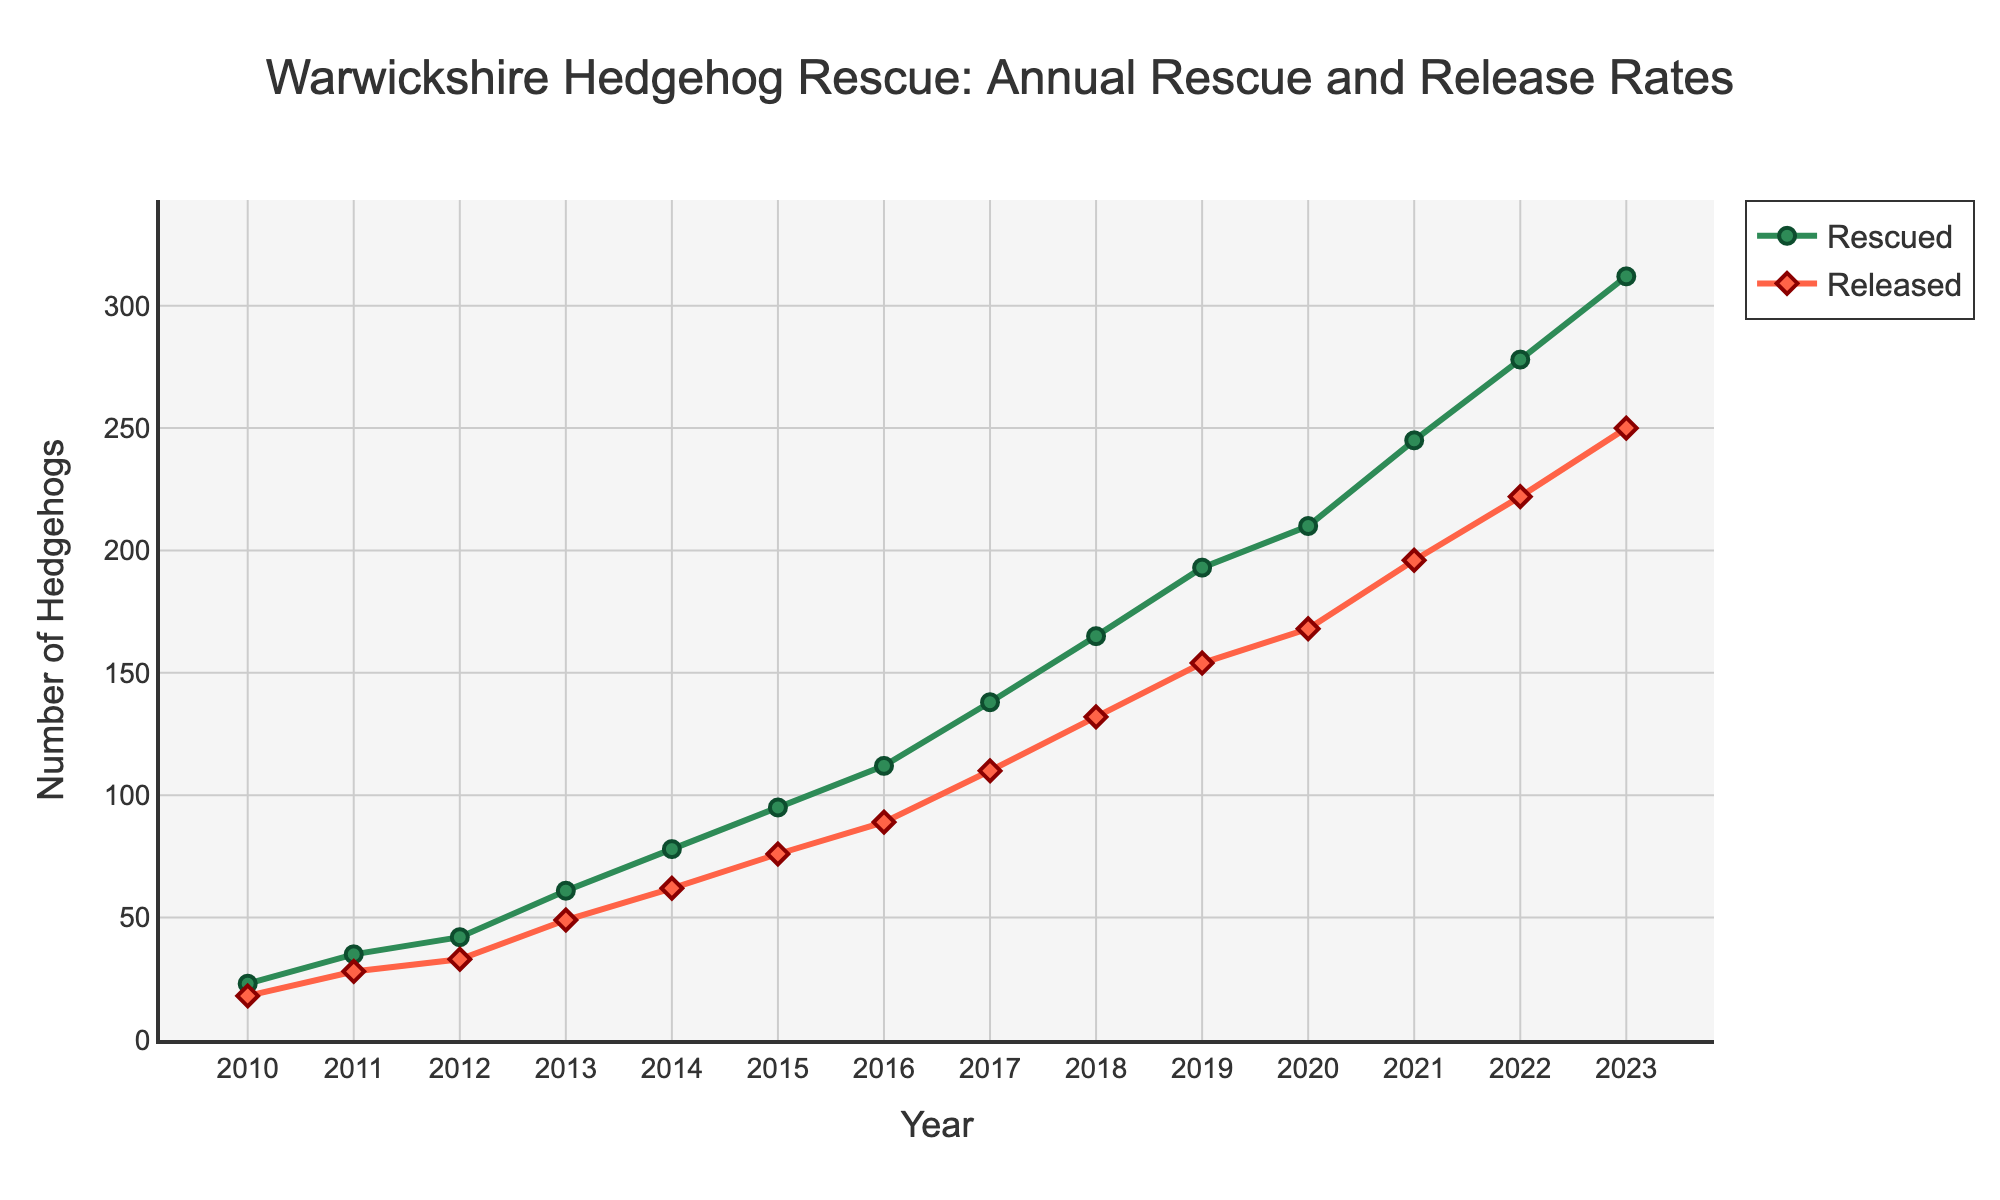What was the total number of hedgehogs rescued over the entire period? Sum the values of the 'Rescued' column: 23 + 35 + 42 + 61 + 78 + 95 + 112 + 138 + 165 + 193 + 210 + 245 + 278 + 312 = 1987
Answer: 1987 In which year did the number of hedgehogs released first exceed 100? Look through the 'Released' values and find the first year where the value exceeds 100. The value first exceeds 100 in 2017.
Answer: 2017 How did the number of hedgehogs rescued in 2015 compare to those released in 2015? The number of hedgehogs rescued in 2015 is 95 while the number released is 76. 95 is greater than 76.
Answer: Greater What is the percentage increase in hedgehogs rescued from 2010 to 2023? Calculate the percentage increase: ((Rescued in 2023 - Rescued in 2010) / Rescued in 2010) * 100 = ((312 - 23) / 23) * 100 = 1256.52%
Answer: 1256.52% On average, how many hedgehogs were released each year between 2010 and 2023? Calculate the average by summing the 'Released' values and dividing by the number of years: (18 + 28 + 33 + 49 + 62 + 76 + 89 + 110 + 132 + 154 + 168 + 196 + 222 + 250) / 14 ≈ 118.79
Answer: 118.79 By how much did the number of hedgehogs rescued increase from 2019 to 2020? Subtract the number of rescued hedgehogs in 2019 from those in 2020: 210 - 193 = 17
Answer: 17 Which year saw the greatest absolute increase in the number of hedgehogs rescued compared to the previous year? Compare the yearly changes in 'Rescued' values. The largest increase is from 67 hedgehogs, which occurred between 2022 and 2023 (312 - 245 = 67).
Answer: 2023 Which color represents the 'Released' hedgehogs in the plot? The 'Released' hedgehogs are shown with red lines and diamond markers.
Answer: Red Identify the year with the smallest gap between the numbers of rescued and released hedgehogs. What was the gap? Calculate the difference for each year and find the smallest gap: Minimum gap is in 2021 with (245 - 196 = 49).
Answer: 2021, 49 From 2010 to 2023, how many years did the number of hedgehogs released exceed 50? Count the years with 'Released' values greater than 50: 2014, 2015, 2016, 2017, 2018, 2019, 2020, 2021, 2022, 2023.
Answer: 10 